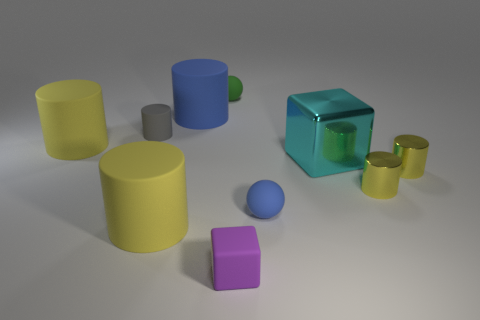There is a matte object that is right of the blue cylinder and behind the gray cylinder; what color is it? The matte object positioned to the right of the blue cylinder and behind the gray cylinder has a pleasant green hue, contributing to the image's overall colorful array of objects with varied shapes and transparencies. 